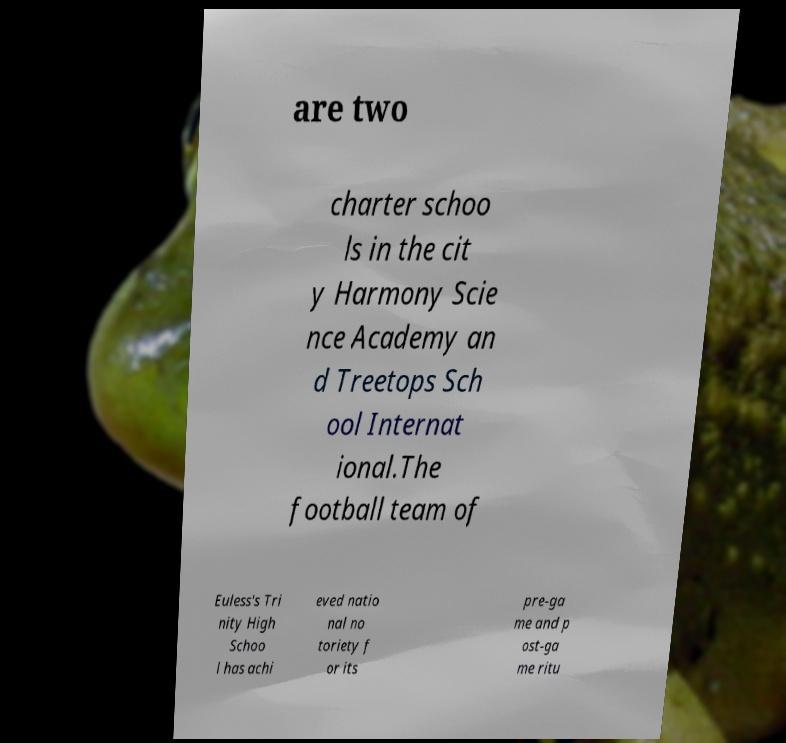Could you extract and type out the text from this image? are two charter schoo ls in the cit y Harmony Scie nce Academy an d Treetops Sch ool Internat ional.The football team of Euless's Tri nity High Schoo l has achi eved natio nal no toriety f or its pre-ga me and p ost-ga me ritu 